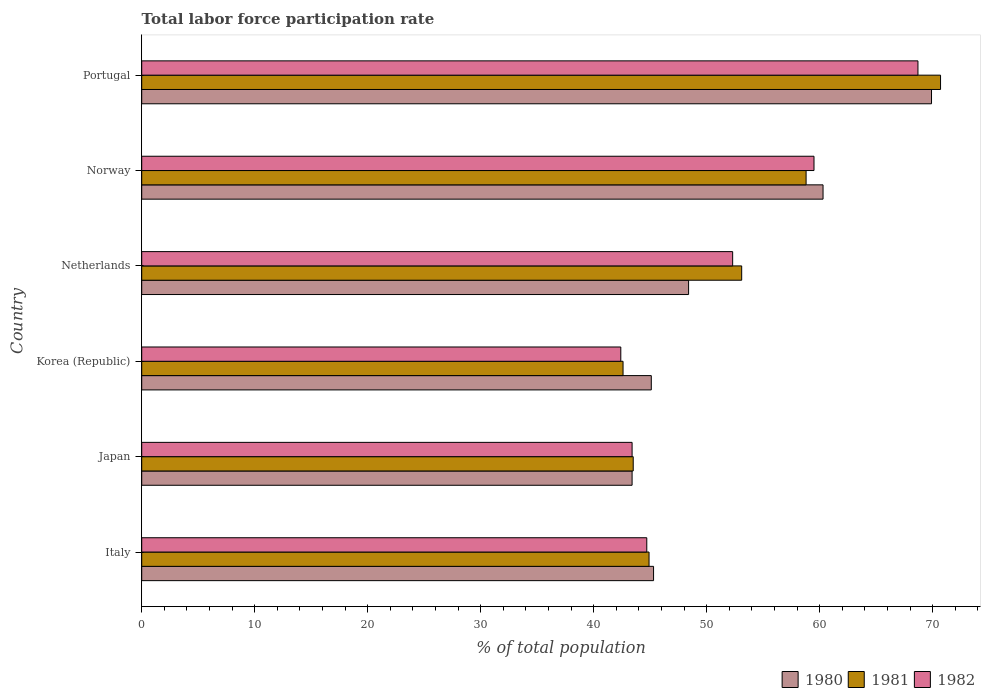Are the number of bars on each tick of the Y-axis equal?
Ensure brevity in your answer.  Yes. How many bars are there on the 1st tick from the bottom?
Your answer should be compact. 3. What is the label of the 3rd group of bars from the top?
Provide a succinct answer. Netherlands. What is the total labor force participation rate in 1981 in Portugal?
Give a very brief answer. 70.7. Across all countries, what is the maximum total labor force participation rate in 1980?
Offer a terse response. 69.9. Across all countries, what is the minimum total labor force participation rate in 1982?
Provide a short and direct response. 42.4. In which country was the total labor force participation rate in 1980 maximum?
Your answer should be compact. Portugal. What is the total total labor force participation rate in 1981 in the graph?
Give a very brief answer. 313.6. What is the difference between the total labor force participation rate in 1981 in Italy and that in Netherlands?
Offer a very short reply. -8.2. What is the difference between the total labor force participation rate in 1980 in Italy and the total labor force participation rate in 1981 in Korea (Republic)?
Ensure brevity in your answer.  2.7. What is the average total labor force participation rate in 1982 per country?
Offer a very short reply. 51.83. What is the difference between the total labor force participation rate in 1981 and total labor force participation rate in 1982 in Norway?
Give a very brief answer. -0.7. In how many countries, is the total labor force participation rate in 1981 greater than 38 %?
Offer a terse response. 6. What is the ratio of the total labor force participation rate in 1980 in Italy to that in Norway?
Your answer should be very brief. 0.75. Is the total labor force participation rate in 1980 in Japan less than that in Norway?
Give a very brief answer. Yes. Is the difference between the total labor force participation rate in 1981 in Japan and Korea (Republic) greater than the difference between the total labor force participation rate in 1982 in Japan and Korea (Republic)?
Give a very brief answer. No. What is the difference between the highest and the second highest total labor force participation rate in 1980?
Provide a succinct answer. 9.6. What is the difference between the highest and the lowest total labor force participation rate in 1980?
Offer a terse response. 26.5. What does the 3rd bar from the bottom in Japan represents?
Your response must be concise. 1982. How many bars are there?
Your answer should be compact. 18. Are all the bars in the graph horizontal?
Provide a succinct answer. Yes. Does the graph contain any zero values?
Your response must be concise. No. Does the graph contain grids?
Provide a succinct answer. No. Where does the legend appear in the graph?
Make the answer very short. Bottom right. How many legend labels are there?
Offer a terse response. 3. What is the title of the graph?
Your response must be concise. Total labor force participation rate. Does "1967" appear as one of the legend labels in the graph?
Offer a terse response. No. What is the label or title of the X-axis?
Offer a terse response. % of total population. What is the % of total population in 1980 in Italy?
Give a very brief answer. 45.3. What is the % of total population of 1981 in Italy?
Provide a succinct answer. 44.9. What is the % of total population of 1982 in Italy?
Give a very brief answer. 44.7. What is the % of total population in 1980 in Japan?
Your response must be concise. 43.4. What is the % of total population of 1981 in Japan?
Provide a succinct answer. 43.5. What is the % of total population in 1982 in Japan?
Your answer should be compact. 43.4. What is the % of total population in 1980 in Korea (Republic)?
Offer a terse response. 45.1. What is the % of total population in 1981 in Korea (Republic)?
Keep it short and to the point. 42.6. What is the % of total population in 1982 in Korea (Republic)?
Offer a terse response. 42.4. What is the % of total population in 1980 in Netherlands?
Make the answer very short. 48.4. What is the % of total population of 1981 in Netherlands?
Keep it short and to the point. 53.1. What is the % of total population in 1982 in Netherlands?
Your answer should be compact. 52.3. What is the % of total population of 1980 in Norway?
Provide a succinct answer. 60.3. What is the % of total population of 1981 in Norway?
Your response must be concise. 58.8. What is the % of total population in 1982 in Norway?
Your answer should be compact. 59.5. What is the % of total population in 1980 in Portugal?
Provide a succinct answer. 69.9. What is the % of total population in 1981 in Portugal?
Ensure brevity in your answer.  70.7. What is the % of total population of 1982 in Portugal?
Give a very brief answer. 68.7. Across all countries, what is the maximum % of total population of 1980?
Offer a very short reply. 69.9. Across all countries, what is the maximum % of total population of 1981?
Provide a short and direct response. 70.7. Across all countries, what is the maximum % of total population in 1982?
Give a very brief answer. 68.7. Across all countries, what is the minimum % of total population in 1980?
Give a very brief answer. 43.4. Across all countries, what is the minimum % of total population of 1981?
Offer a terse response. 42.6. Across all countries, what is the minimum % of total population of 1982?
Your answer should be very brief. 42.4. What is the total % of total population in 1980 in the graph?
Make the answer very short. 312.4. What is the total % of total population of 1981 in the graph?
Your answer should be compact. 313.6. What is the total % of total population of 1982 in the graph?
Your answer should be compact. 311. What is the difference between the % of total population of 1980 in Italy and that in Japan?
Your answer should be compact. 1.9. What is the difference between the % of total population in 1980 in Italy and that in Norway?
Offer a terse response. -15. What is the difference between the % of total population in 1981 in Italy and that in Norway?
Make the answer very short. -13.9. What is the difference between the % of total population of 1982 in Italy and that in Norway?
Your response must be concise. -14.8. What is the difference between the % of total population of 1980 in Italy and that in Portugal?
Give a very brief answer. -24.6. What is the difference between the % of total population in 1981 in Italy and that in Portugal?
Provide a short and direct response. -25.8. What is the difference between the % of total population of 1980 in Japan and that in Korea (Republic)?
Provide a short and direct response. -1.7. What is the difference between the % of total population in 1981 in Japan and that in Korea (Republic)?
Ensure brevity in your answer.  0.9. What is the difference between the % of total population of 1982 in Japan and that in Korea (Republic)?
Your answer should be very brief. 1. What is the difference between the % of total population in 1980 in Japan and that in Netherlands?
Your answer should be very brief. -5. What is the difference between the % of total population in 1981 in Japan and that in Netherlands?
Provide a succinct answer. -9.6. What is the difference between the % of total population in 1980 in Japan and that in Norway?
Your response must be concise. -16.9. What is the difference between the % of total population of 1981 in Japan and that in Norway?
Make the answer very short. -15.3. What is the difference between the % of total population in 1982 in Japan and that in Norway?
Give a very brief answer. -16.1. What is the difference between the % of total population in 1980 in Japan and that in Portugal?
Offer a terse response. -26.5. What is the difference between the % of total population in 1981 in Japan and that in Portugal?
Your answer should be very brief. -27.2. What is the difference between the % of total population in 1982 in Japan and that in Portugal?
Make the answer very short. -25.3. What is the difference between the % of total population of 1980 in Korea (Republic) and that in Norway?
Your answer should be very brief. -15.2. What is the difference between the % of total population in 1981 in Korea (Republic) and that in Norway?
Offer a terse response. -16.2. What is the difference between the % of total population of 1982 in Korea (Republic) and that in Norway?
Offer a terse response. -17.1. What is the difference between the % of total population of 1980 in Korea (Republic) and that in Portugal?
Offer a terse response. -24.8. What is the difference between the % of total population of 1981 in Korea (Republic) and that in Portugal?
Make the answer very short. -28.1. What is the difference between the % of total population of 1982 in Korea (Republic) and that in Portugal?
Provide a short and direct response. -26.3. What is the difference between the % of total population in 1982 in Netherlands and that in Norway?
Keep it short and to the point. -7.2. What is the difference between the % of total population in 1980 in Netherlands and that in Portugal?
Your answer should be very brief. -21.5. What is the difference between the % of total population in 1981 in Netherlands and that in Portugal?
Keep it short and to the point. -17.6. What is the difference between the % of total population in 1982 in Netherlands and that in Portugal?
Make the answer very short. -16.4. What is the difference between the % of total population of 1980 in Norway and that in Portugal?
Your answer should be very brief. -9.6. What is the difference between the % of total population in 1982 in Norway and that in Portugal?
Offer a terse response. -9.2. What is the difference between the % of total population of 1980 in Italy and the % of total population of 1981 in Japan?
Keep it short and to the point. 1.8. What is the difference between the % of total population in 1980 in Italy and the % of total population in 1982 in Japan?
Your response must be concise. 1.9. What is the difference between the % of total population of 1981 in Italy and the % of total population of 1982 in Japan?
Offer a terse response. 1.5. What is the difference between the % of total population of 1980 in Italy and the % of total population of 1981 in Korea (Republic)?
Ensure brevity in your answer.  2.7. What is the difference between the % of total population of 1980 in Italy and the % of total population of 1982 in Korea (Republic)?
Provide a succinct answer. 2.9. What is the difference between the % of total population of 1980 in Italy and the % of total population of 1981 in Netherlands?
Give a very brief answer. -7.8. What is the difference between the % of total population of 1981 in Italy and the % of total population of 1982 in Netherlands?
Keep it short and to the point. -7.4. What is the difference between the % of total population of 1980 in Italy and the % of total population of 1981 in Norway?
Ensure brevity in your answer.  -13.5. What is the difference between the % of total population in 1981 in Italy and the % of total population in 1982 in Norway?
Your answer should be very brief. -14.6. What is the difference between the % of total population in 1980 in Italy and the % of total population in 1981 in Portugal?
Provide a succinct answer. -25.4. What is the difference between the % of total population in 1980 in Italy and the % of total population in 1982 in Portugal?
Make the answer very short. -23.4. What is the difference between the % of total population in 1981 in Italy and the % of total population in 1982 in Portugal?
Make the answer very short. -23.8. What is the difference between the % of total population in 1980 in Japan and the % of total population in 1981 in Korea (Republic)?
Give a very brief answer. 0.8. What is the difference between the % of total population in 1981 in Japan and the % of total population in 1982 in Korea (Republic)?
Keep it short and to the point. 1.1. What is the difference between the % of total population in 1980 in Japan and the % of total population in 1981 in Netherlands?
Your response must be concise. -9.7. What is the difference between the % of total population in 1981 in Japan and the % of total population in 1982 in Netherlands?
Make the answer very short. -8.8. What is the difference between the % of total population of 1980 in Japan and the % of total population of 1981 in Norway?
Keep it short and to the point. -15.4. What is the difference between the % of total population of 1980 in Japan and the % of total population of 1982 in Norway?
Your answer should be compact. -16.1. What is the difference between the % of total population of 1980 in Japan and the % of total population of 1981 in Portugal?
Provide a short and direct response. -27.3. What is the difference between the % of total population of 1980 in Japan and the % of total population of 1982 in Portugal?
Make the answer very short. -25.3. What is the difference between the % of total population of 1981 in Japan and the % of total population of 1982 in Portugal?
Offer a terse response. -25.2. What is the difference between the % of total population in 1980 in Korea (Republic) and the % of total population in 1981 in Netherlands?
Your response must be concise. -8. What is the difference between the % of total population of 1980 in Korea (Republic) and the % of total population of 1982 in Netherlands?
Make the answer very short. -7.2. What is the difference between the % of total population in 1981 in Korea (Republic) and the % of total population in 1982 in Netherlands?
Offer a very short reply. -9.7. What is the difference between the % of total population in 1980 in Korea (Republic) and the % of total population in 1981 in Norway?
Keep it short and to the point. -13.7. What is the difference between the % of total population of 1980 in Korea (Republic) and the % of total population of 1982 in Norway?
Give a very brief answer. -14.4. What is the difference between the % of total population of 1981 in Korea (Republic) and the % of total population of 1982 in Norway?
Your answer should be very brief. -16.9. What is the difference between the % of total population in 1980 in Korea (Republic) and the % of total population in 1981 in Portugal?
Your response must be concise. -25.6. What is the difference between the % of total population of 1980 in Korea (Republic) and the % of total population of 1982 in Portugal?
Provide a short and direct response. -23.6. What is the difference between the % of total population of 1981 in Korea (Republic) and the % of total population of 1982 in Portugal?
Your answer should be very brief. -26.1. What is the difference between the % of total population of 1980 in Netherlands and the % of total population of 1981 in Portugal?
Offer a very short reply. -22.3. What is the difference between the % of total population in 1980 in Netherlands and the % of total population in 1982 in Portugal?
Give a very brief answer. -20.3. What is the difference between the % of total population in 1981 in Netherlands and the % of total population in 1982 in Portugal?
Give a very brief answer. -15.6. What is the average % of total population in 1980 per country?
Ensure brevity in your answer.  52.07. What is the average % of total population in 1981 per country?
Your response must be concise. 52.27. What is the average % of total population in 1982 per country?
Your response must be concise. 51.83. What is the difference between the % of total population in 1980 and % of total population in 1981 in Italy?
Make the answer very short. 0.4. What is the difference between the % of total population in 1981 and % of total population in 1982 in Italy?
Keep it short and to the point. 0.2. What is the difference between the % of total population in 1980 and % of total population in 1982 in Japan?
Provide a succinct answer. 0. What is the difference between the % of total population of 1981 and % of total population of 1982 in Japan?
Ensure brevity in your answer.  0.1. What is the difference between the % of total population in 1980 and % of total population in 1981 in Korea (Republic)?
Your response must be concise. 2.5. What is the difference between the % of total population in 1980 and % of total population in 1981 in Netherlands?
Provide a short and direct response. -4.7. What is the difference between the % of total population of 1980 and % of total population of 1982 in Netherlands?
Provide a succinct answer. -3.9. What is the difference between the % of total population in 1980 and % of total population in 1982 in Norway?
Give a very brief answer. 0.8. What is the difference between the % of total population in 1980 and % of total population in 1982 in Portugal?
Your response must be concise. 1.2. What is the ratio of the % of total population in 1980 in Italy to that in Japan?
Offer a terse response. 1.04. What is the ratio of the % of total population in 1981 in Italy to that in Japan?
Provide a short and direct response. 1.03. What is the ratio of the % of total population of 1982 in Italy to that in Japan?
Your answer should be very brief. 1.03. What is the ratio of the % of total population in 1980 in Italy to that in Korea (Republic)?
Provide a short and direct response. 1. What is the ratio of the % of total population in 1981 in Italy to that in Korea (Republic)?
Offer a very short reply. 1.05. What is the ratio of the % of total population in 1982 in Italy to that in Korea (Republic)?
Your answer should be compact. 1.05. What is the ratio of the % of total population in 1980 in Italy to that in Netherlands?
Your answer should be compact. 0.94. What is the ratio of the % of total population of 1981 in Italy to that in Netherlands?
Make the answer very short. 0.85. What is the ratio of the % of total population of 1982 in Italy to that in Netherlands?
Your answer should be very brief. 0.85. What is the ratio of the % of total population in 1980 in Italy to that in Norway?
Offer a terse response. 0.75. What is the ratio of the % of total population in 1981 in Italy to that in Norway?
Ensure brevity in your answer.  0.76. What is the ratio of the % of total population in 1982 in Italy to that in Norway?
Give a very brief answer. 0.75. What is the ratio of the % of total population in 1980 in Italy to that in Portugal?
Your answer should be compact. 0.65. What is the ratio of the % of total population in 1981 in Italy to that in Portugal?
Keep it short and to the point. 0.64. What is the ratio of the % of total population of 1982 in Italy to that in Portugal?
Provide a succinct answer. 0.65. What is the ratio of the % of total population of 1980 in Japan to that in Korea (Republic)?
Give a very brief answer. 0.96. What is the ratio of the % of total population in 1981 in Japan to that in Korea (Republic)?
Your response must be concise. 1.02. What is the ratio of the % of total population in 1982 in Japan to that in Korea (Republic)?
Your answer should be very brief. 1.02. What is the ratio of the % of total population of 1980 in Japan to that in Netherlands?
Offer a terse response. 0.9. What is the ratio of the % of total population of 1981 in Japan to that in Netherlands?
Keep it short and to the point. 0.82. What is the ratio of the % of total population in 1982 in Japan to that in Netherlands?
Ensure brevity in your answer.  0.83. What is the ratio of the % of total population of 1980 in Japan to that in Norway?
Give a very brief answer. 0.72. What is the ratio of the % of total population in 1981 in Japan to that in Norway?
Make the answer very short. 0.74. What is the ratio of the % of total population in 1982 in Japan to that in Norway?
Ensure brevity in your answer.  0.73. What is the ratio of the % of total population of 1980 in Japan to that in Portugal?
Give a very brief answer. 0.62. What is the ratio of the % of total population in 1981 in Japan to that in Portugal?
Make the answer very short. 0.62. What is the ratio of the % of total population of 1982 in Japan to that in Portugal?
Provide a succinct answer. 0.63. What is the ratio of the % of total population of 1980 in Korea (Republic) to that in Netherlands?
Provide a succinct answer. 0.93. What is the ratio of the % of total population in 1981 in Korea (Republic) to that in Netherlands?
Offer a terse response. 0.8. What is the ratio of the % of total population of 1982 in Korea (Republic) to that in Netherlands?
Give a very brief answer. 0.81. What is the ratio of the % of total population in 1980 in Korea (Republic) to that in Norway?
Your answer should be compact. 0.75. What is the ratio of the % of total population in 1981 in Korea (Republic) to that in Norway?
Give a very brief answer. 0.72. What is the ratio of the % of total population of 1982 in Korea (Republic) to that in Norway?
Offer a terse response. 0.71. What is the ratio of the % of total population in 1980 in Korea (Republic) to that in Portugal?
Offer a very short reply. 0.65. What is the ratio of the % of total population in 1981 in Korea (Republic) to that in Portugal?
Your answer should be compact. 0.6. What is the ratio of the % of total population of 1982 in Korea (Republic) to that in Portugal?
Offer a terse response. 0.62. What is the ratio of the % of total population in 1980 in Netherlands to that in Norway?
Your answer should be very brief. 0.8. What is the ratio of the % of total population in 1981 in Netherlands to that in Norway?
Provide a short and direct response. 0.9. What is the ratio of the % of total population of 1982 in Netherlands to that in Norway?
Offer a very short reply. 0.88. What is the ratio of the % of total population of 1980 in Netherlands to that in Portugal?
Ensure brevity in your answer.  0.69. What is the ratio of the % of total population in 1981 in Netherlands to that in Portugal?
Offer a very short reply. 0.75. What is the ratio of the % of total population of 1982 in Netherlands to that in Portugal?
Offer a terse response. 0.76. What is the ratio of the % of total population of 1980 in Norway to that in Portugal?
Offer a very short reply. 0.86. What is the ratio of the % of total population of 1981 in Norway to that in Portugal?
Keep it short and to the point. 0.83. What is the ratio of the % of total population in 1982 in Norway to that in Portugal?
Your answer should be compact. 0.87. What is the difference between the highest and the second highest % of total population in 1981?
Provide a short and direct response. 11.9. What is the difference between the highest and the second highest % of total population in 1982?
Ensure brevity in your answer.  9.2. What is the difference between the highest and the lowest % of total population of 1981?
Your response must be concise. 28.1. What is the difference between the highest and the lowest % of total population in 1982?
Provide a short and direct response. 26.3. 